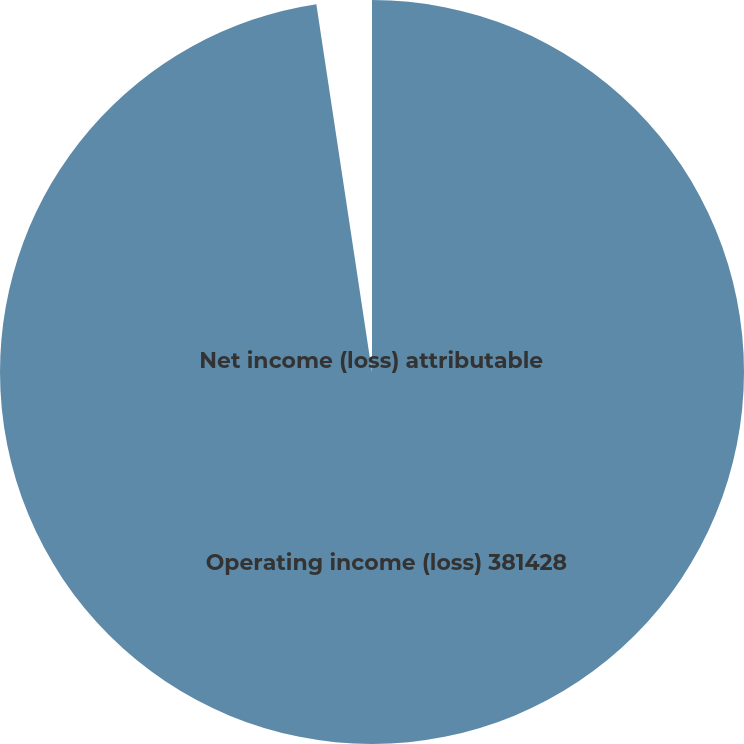Convert chart. <chart><loc_0><loc_0><loc_500><loc_500><pie_chart><fcel>Operating income (loss) 381428<fcel>Net income (loss) attributable<nl><fcel>97.61%<fcel>2.39%<nl></chart> 